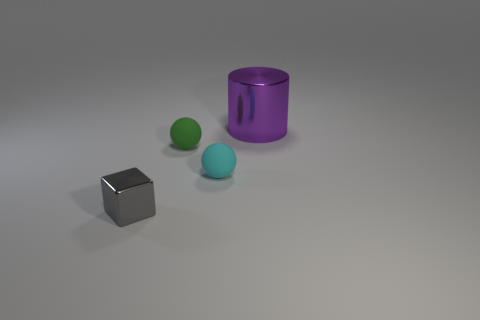Do the purple thing and the tiny gray metallic object have the same shape?
Your answer should be very brief. No. The metallic thing in front of the shiny object that is on the right side of the shiny thing that is in front of the cylinder is what color?
Ensure brevity in your answer.  Gray. How many cyan objects are the same shape as the green rubber thing?
Your answer should be compact. 1. There is a metal thing to the left of the metal thing behind the small gray shiny block; what size is it?
Your response must be concise. Small. Do the purple cylinder and the gray object have the same size?
Provide a short and direct response. No. There is a metallic thing in front of the metallic thing behind the metallic cube; is there a small cyan rubber thing that is to the right of it?
Offer a very short reply. Yes. How big is the purple shiny object?
Make the answer very short. Large. What number of cyan spheres have the same size as the green matte sphere?
Give a very brief answer. 1. There is another small thing that is the same shape as the green object; what is it made of?
Give a very brief answer. Rubber. What shape is the tiny thing that is both to the left of the tiny cyan matte object and to the right of the small gray cube?
Keep it short and to the point. Sphere. 